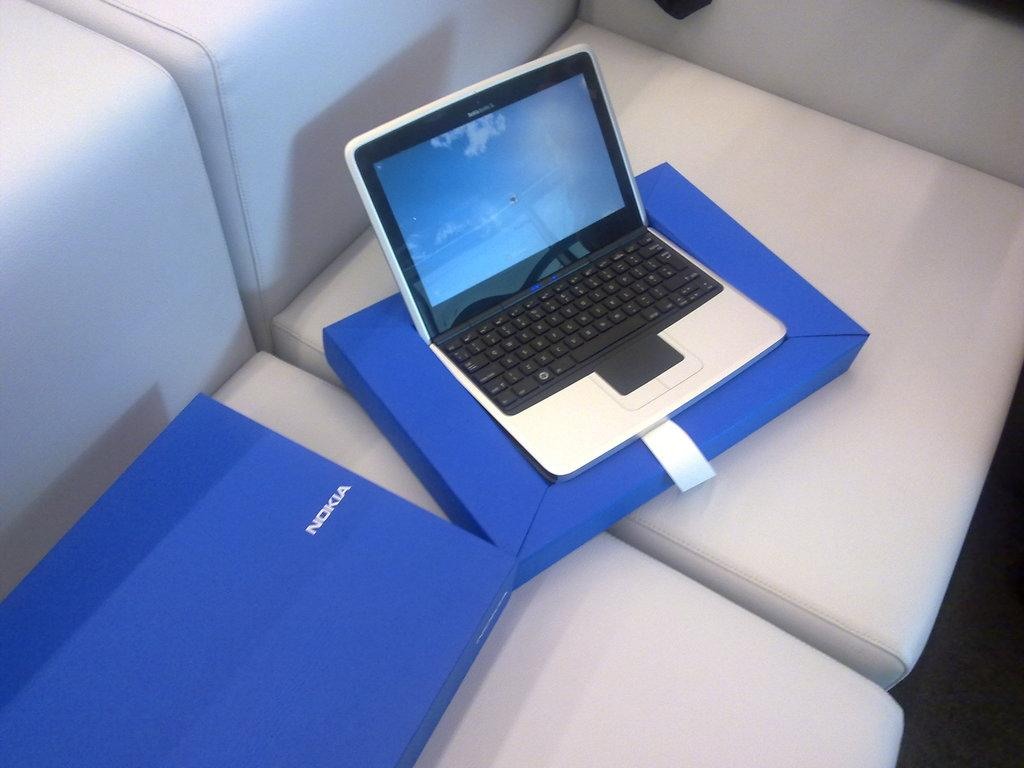Provide a one-sentence caption for the provided image. Nokia laptop sitting on top of a blue Nokia box. 